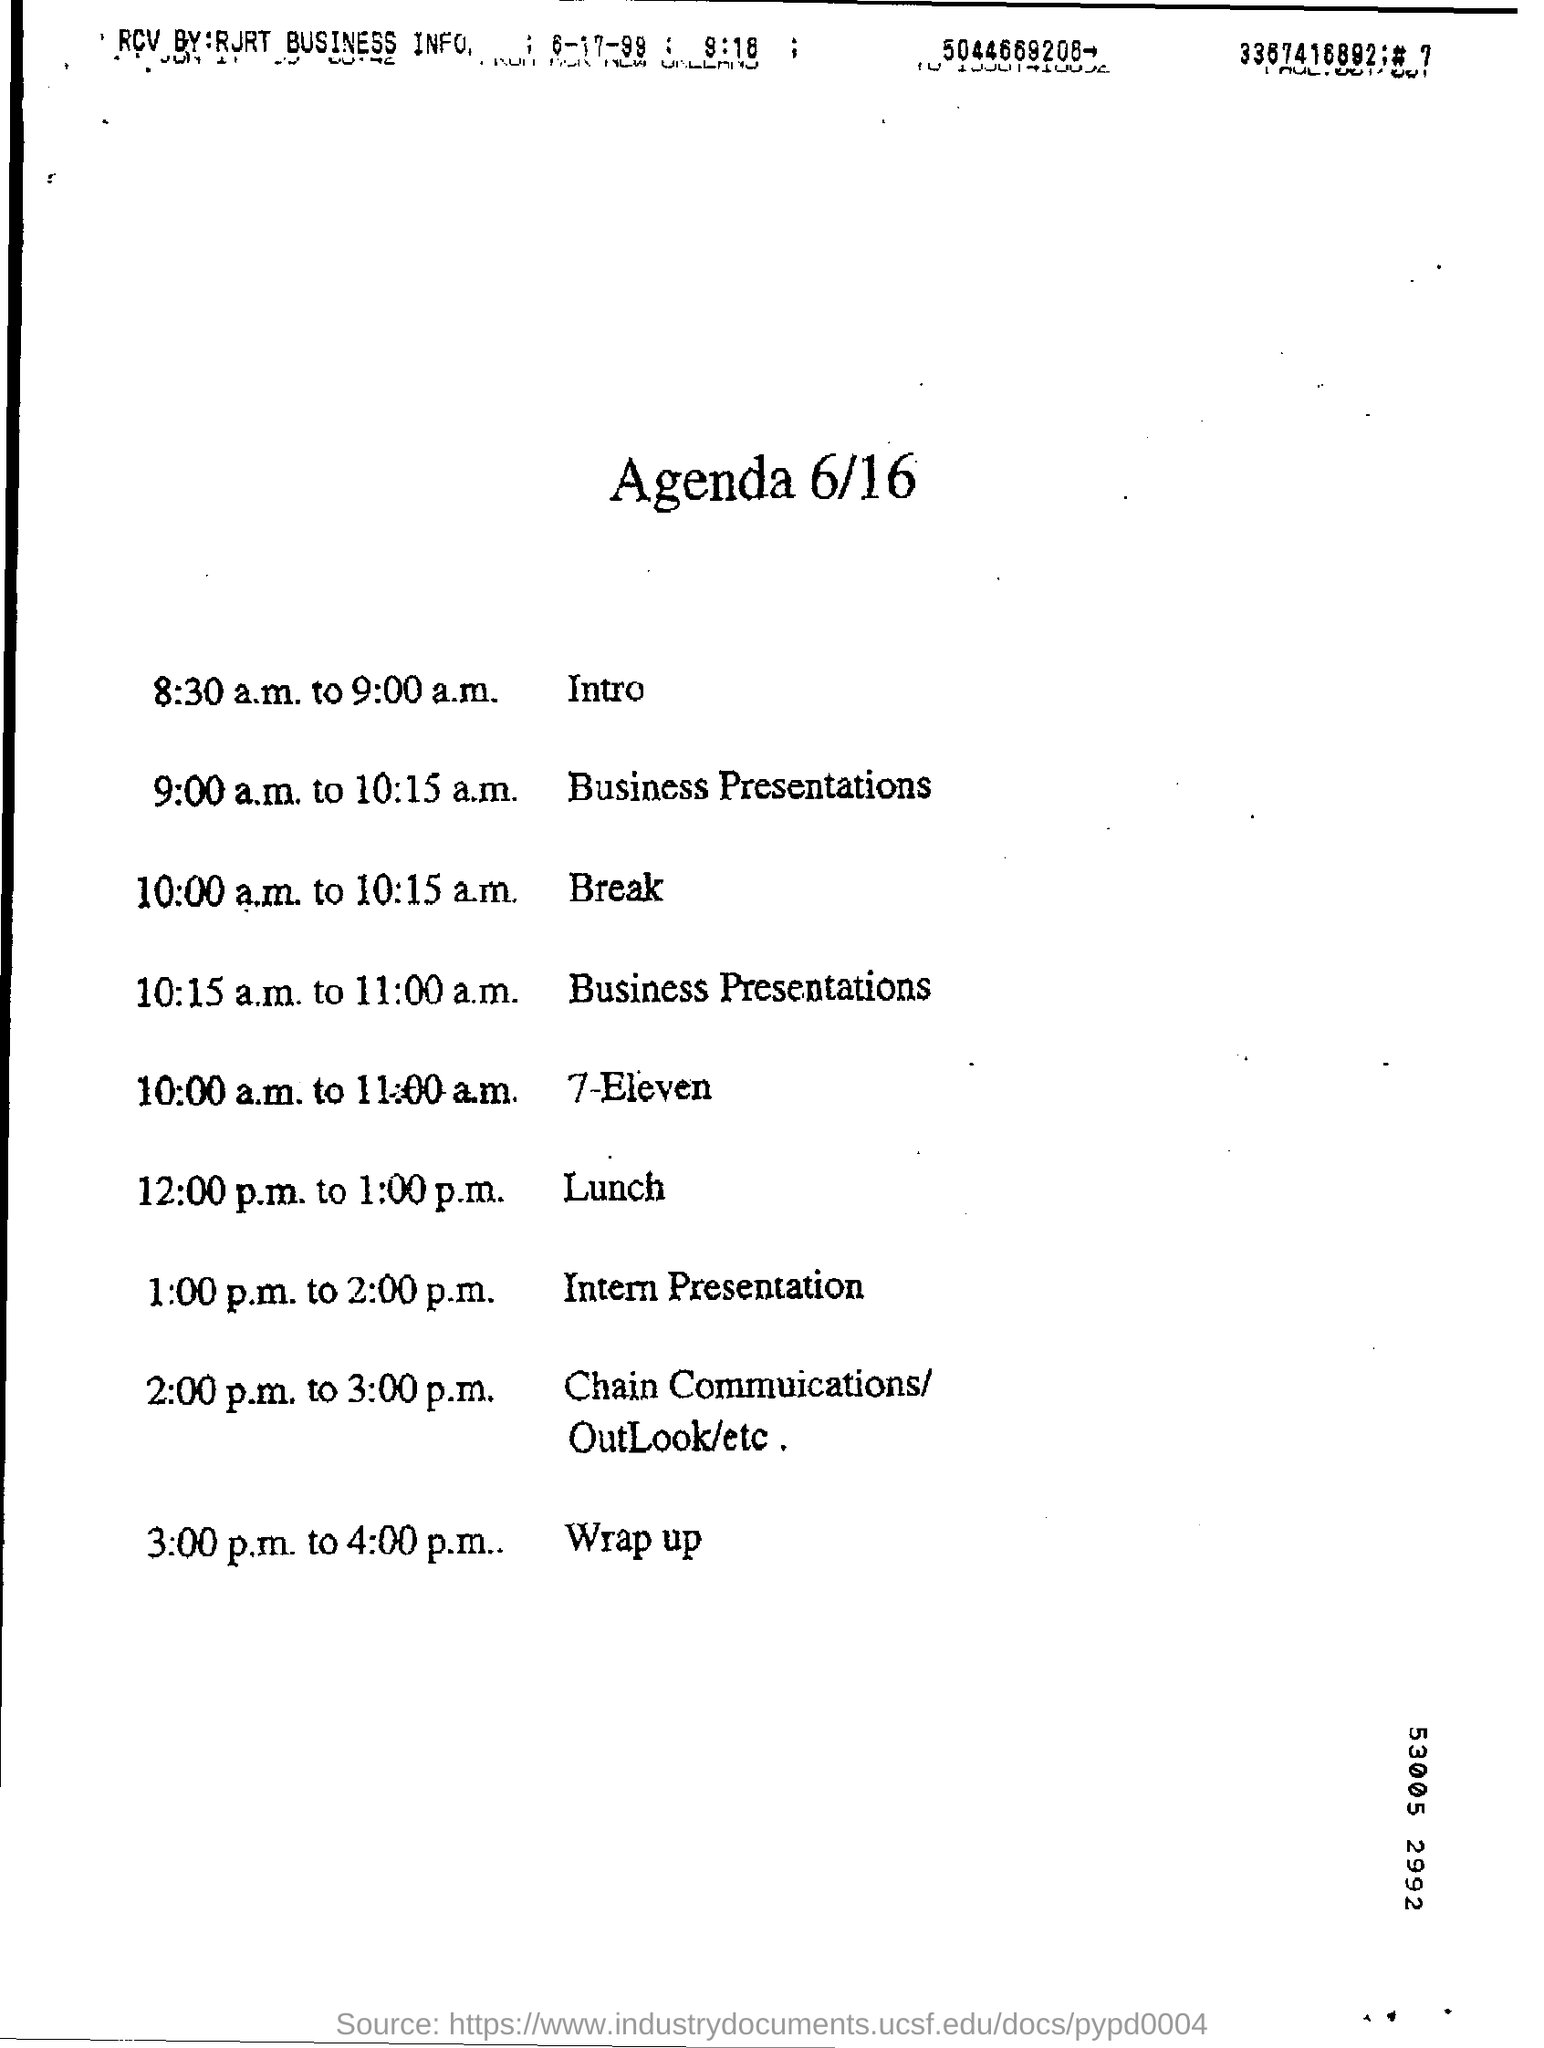Draw attention to some important aspects in this diagram. The break time was from 10:00 a.m. to 10:15 a.m. The time of the introduction is 8:30 a.m. to 9:00 a.m. 